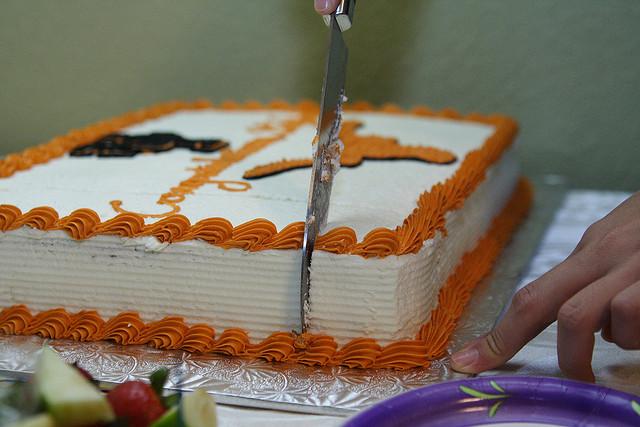What is the person cutting?
Write a very short answer. Cake. What is the dairy product in this meal?
Keep it brief. Milk. What colors are the cake?
Short answer required. White and orange. How many food items are there?
Give a very brief answer. 1. What color is the cake?
Answer briefly. White. 